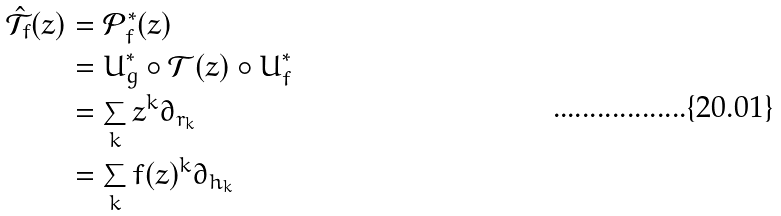Convert formula to latex. <formula><loc_0><loc_0><loc_500><loc_500>\hat { \mathcal { T } } _ { f } ( z ) & = \mathcal { P } _ { f } ^ { * } ( z ) \\ & = U ^ { * } _ { g } \circ \mathcal { T } ( z ) \circ U ^ { * } _ { f } \\ & = \sum _ { k } z ^ { k } \partial _ { r _ { k } } \\ & = \sum _ { k } f ( z ) ^ { k } \partial _ { h _ { k } }</formula> 